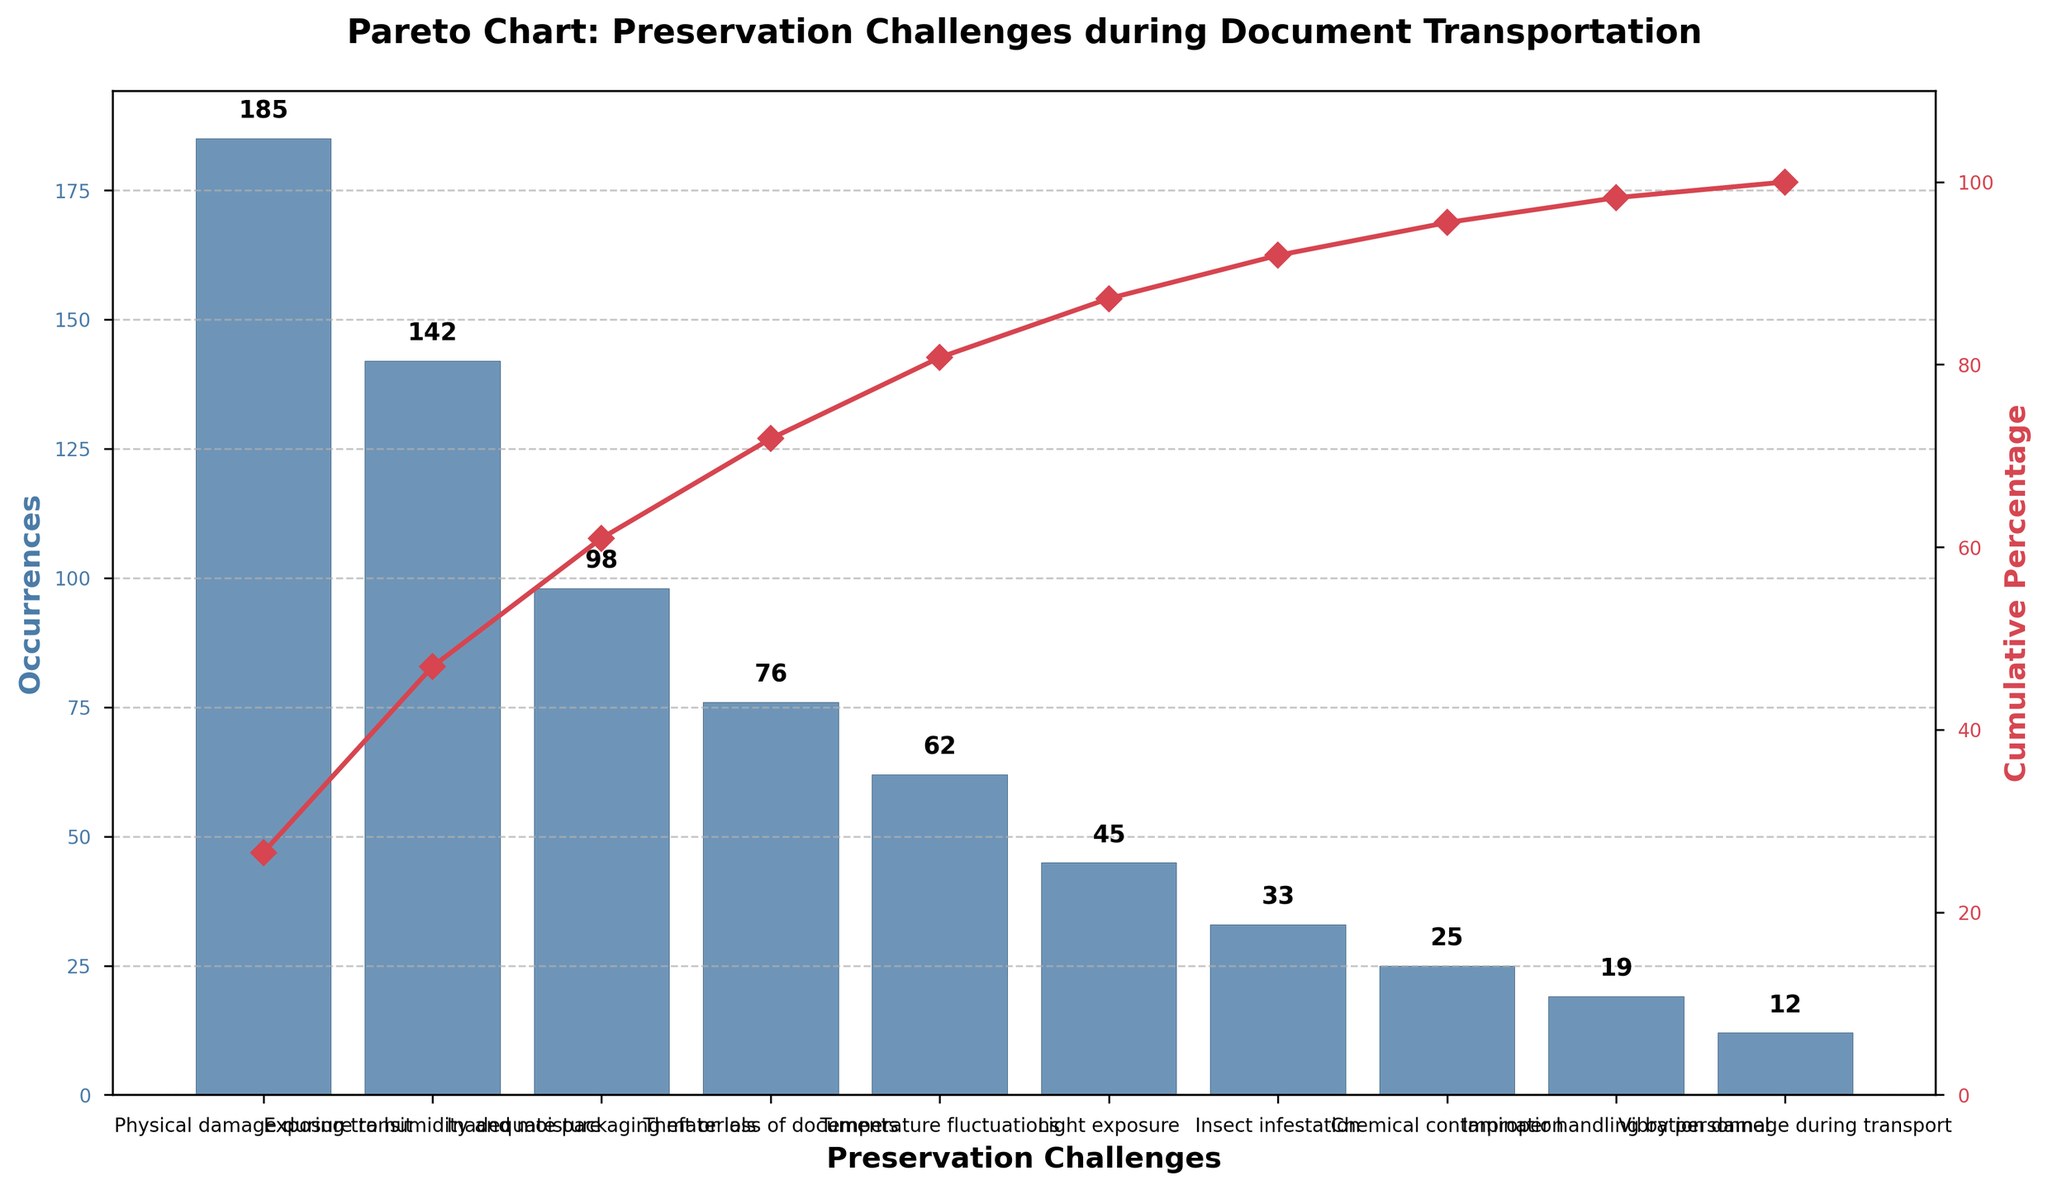What's the title of the chart? The title is found at the top of the figure, and it summarizes the chart's main topic. The title reads "Pareto Chart: Preservation Challenges during Document Transportation."
Answer: Pareto Chart: Preservation Challenges during Document Transportation How many types of preservation challenges are there in the chart? Count the number of distinct bars on the x-axis, each representing a preservation challenge. There are 10 bars, which correspond to 10 types of preservation challenges.
Answer: 10 Which preservation challenge has the highest occurrence? Look for the bar with the greatest height on the leftmost side of the chart. The tallest bar represents "Physical damage during transit," indicating it has the highest occurrence.
Answer: Physical damage during transit What is the cumulative percentage after the second challenge? Identify the cumulative percentage line on the secondary y-axis and locate its value after the second challenge. The first two challenges are "Physical damage during transit" and "Exposure to humidity and moisture." Their cumulative percentage is approximately 56%.
Answer: 56% Compare the occurrences of "Inadequate packaging materials" and "Theft or loss of documents". Which one is higher and by how much? Find the bar heights for both challenges on the x-axis. "Inadequate packaging materials" has 98 occurrences and "Theft or loss of documents" has 76 occurrences. Subtract 76 from 98 to get the difference.
Answer: Inadequate packaging materials by 22 What is the cumulative percentage after the first three challenges? Sum the occurrences of the first three challenges: 185 (Physical damage during transit) + 142 (Exposure to humidity and moisture) + 98 (Inadequate packaging materials) = 425. Divide this sum by the total occurrences (185 + 142 + 98 + 76 + 62 + 45 + 33 + 25 + 19 + 12 = 697) and multiply by 100 to convert to percentage. (425 / 697) * 100 ≈ 61%
Answer: 61% How does the occurrence of "Insect infestation" compare to "Temperature fluctuations"? Find the bar heights for both challenges on the x-axis. "Insect infestation" has 33 occurrences while "Temperature fluctuations" has 62 occurrences. Therefore, "Temperature fluctuations" has a higher occurrence.
Answer: Temperature fluctuations are higher What proportion of the total occurrences does "Chemical contamination" represent? Find the total number of occurrences which is 697. The occurrences for "Chemical contamination" are 25. Divide 25 by 697 and multiply by 100 to get the percentage: (25 / 697) * 100 ≈ 3.6%.
Answer: 3.6% What's the cumulative percentage after "Light exposure"? Sum the occurrences of all challenges up to "Light exposure": 185 + 142 + 98 + 76 + 62 + 45 = 608. Divide this by the total occurrences (697), and multiply by 100. (608 / 697) * 100 ≈ 87%.
Answer: 87% Which challenge has the smallest number of occurrences and what is the exact count? Look for the shortest bar on the x-axis, which represents the challenge with the smallest number of occurrences. The shortest bar corresponds to "Vibration damage during transport" with 12 occurrences.
Answer: Vibration damage during transport with 12 occurrences 